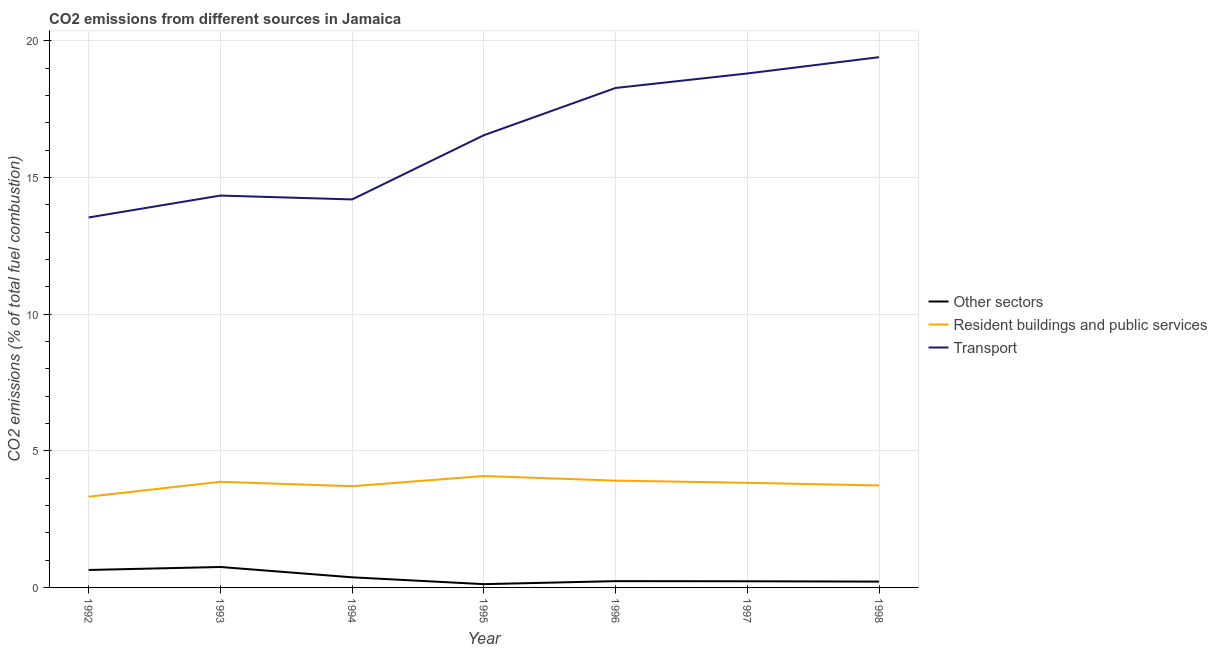Does the line corresponding to percentage of co2 emissions from transport intersect with the line corresponding to percentage of co2 emissions from resident buildings and public services?
Ensure brevity in your answer.  No. What is the percentage of co2 emissions from transport in 1994?
Make the answer very short. 14.2. Across all years, what is the maximum percentage of co2 emissions from transport?
Your answer should be very brief. 19.4. Across all years, what is the minimum percentage of co2 emissions from transport?
Your answer should be very brief. 13.54. In which year was the percentage of co2 emissions from transport minimum?
Keep it short and to the point. 1992. What is the total percentage of co2 emissions from other sectors in the graph?
Offer a very short reply. 2.55. What is the difference between the percentage of co2 emissions from resident buildings and public services in 1994 and that in 1998?
Provide a short and direct response. -0.03. What is the difference between the percentage of co2 emissions from resident buildings and public services in 1995 and the percentage of co2 emissions from transport in 1996?
Your answer should be very brief. -14.2. What is the average percentage of co2 emissions from resident buildings and public services per year?
Provide a succinct answer. 3.78. In the year 1994, what is the difference between the percentage of co2 emissions from other sectors and percentage of co2 emissions from resident buildings and public services?
Your response must be concise. -3.33. What is the ratio of the percentage of co2 emissions from resident buildings and public services in 1994 to that in 1998?
Offer a very short reply. 0.99. Is the percentage of co2 emissions from resident buildings and public services in 1993 less than that in 1998?
Your answer should be compact. No. Is the difference between the percentage of co2 emissions from other sectors in 1993 and 1997 greater than the difference between the percentage of co2 emissions from transport in 1993 and 1997?
Give a very brief answer. Yes. What is the difference between the highest and the second highest percentage of co2 emissions from resident buildings and public services?
Provide a succinct answer. 0.17. What is the difference between the highest and the lowest percentage of co2 emissions from transport?
Your answer should be very brief. 5.87. In how many years, is the percentage of co2 emissions from resident buildings and public services greater than the average percentage of co2 emissions from resident buildings and public services taken over all years?
Provide a short and direct response. 4. Is the sum of the percentage of co2 emissions from transport in 1996 and 1998 greater than the maximum percentage of co2 emissions from other sectors across all years?
Give a very brief answer. Yes. Is the percentage of co2 emissions from transport strictly less than the percentage of co2 emissions from resident buildings and public services over the years?
Offer a very short reply. No. How many lines are there?
Ensure brevity in your answer.  3. How many years are there in the graph?
Your response must be concise. 7. What is the difference between two consecutive major ticks on the Y-axis?
Keep it short and to the point. 5. Are the values on the major ticks of Y-axis written in scientific E-notation?
Ensure brevity in your answer.  No. Does the graph contain any zero values?
Ensure brevity in your answer.  No. Does the graph contain grids?
Provide a succinct answer. Yes. Where does the legend appear in the graph?
Provide a succinct answer. Center right. How many legend labels are there?
Your answer should be compact. 3. How are the legend labels stacked?
Give a very brief answer. Vertical. What is the title of the graph?
Make the answer very short. CO2 emissions from different sources in Jamaica. Does "Social insurance" appear as one of the legend labels in the graph?
Make the answer very short. No. What is the label or title of the X-axis?
Your answer should be very brief. Year. What is the label or title of the Y-axis?
Ensure brevity in your answer.  CO2 emissions (% of total fuel combustion). What is the CO2 emissions (% of total fuel combustion) of Other sectors in 1992?
Make the answer very short. 0.64. What is the CO2 emissions (% of total fuel combustion) of Resident buildings and public services in 1992?
Your response must be concise. 3.32. What is the CO2 emissions (% of total fuel combustion) in Transport in 1992?
Your answer should be compact. 13.54. What is the CO2 emissions (% of total fuel combustion) of Other sectors in 1993?
Ensure brevity in your answer.  0.75. What is the CO2 emissions (% of total fuel combustion) in Resident buildings and public services in 1993?
Your answer should be compact. 3.87. What is the CO2 emissions (% of total fuel combustion) in Transport in 1993?
Ensure brevity in your answer.  14.34. What is the CO2 emissions (% of total fuel combustion) of Other sectors in 1994?
Keep it short and to the point. 0.37. What is the CO2 emissions (% of total fuel combustion) in Resident buildings and public services in 1994?
Provide a succinct answer. 3.7. What is the CO2 emissions (% of total fuel combustion) of Transport in 1994?
Provide a short and direct response. 14.2. What is the CO2 emissions (% of total fuel combustion) in Other sectors in 1995?
Offer a very short reply. 0.12. What is the CO2 emissions (% of total fuel combustion) of Resident buildings and public services in 1995?
Offer a very short reply. 4.08. What is the CO2 emissions (% of total fuel combustion) of Transport in 1995?
Keep it short and to the point. 16.55. What is the CO2 emissions (% of total fuel combustion) in Other sectors in 1996?
Your answer should be very brief. 0.23. What is the CO2 emissions (% of total fuel combustion) in Resident buildings and public services in 1996?
Your answer should be compact. 3.91. What is the CO2 emissions (% of total fuel combustion) in Transport in 1996?
Keep it short and to the point. 18.28. What is the CO2 emissions (% of total fuel combustion) in Other sectors in 1997?
Provide a short and direct response. 0.23. What is the CO2 emissions (% of total fuel combustion) in Resident buildings and public services in 1997?
Provide a short and direct response. 3.83. What is the CO2 emissions (% of total fuel combustion) in Transport in 1997?
Make the answer very short. 18.81. What is the CO2 emissions (% of total fuel combustion) in Other sectors in 1998?
Make the answer very short. 0.21. What is the CO2 emissions (% of total fuel combustion) in Resident buildings and public services in 1998?
Provide a short and direct response. 3.73. What is the CO2 emissions (% of total fuel combustion) of Transport in 1998?
Your answer should be very brief. 19.4. Across all years, what is the maximum CO2 emissions (% of total fuel combustion) in Other sectors?
Keep it short and to the point. 0.75. Across all years, what is the maximum CO2 emissions (% of total fuel combustion) in Resident buildings and public services?
Provide a succinct answer. 4.08. Across all years, what is the maximum CO2 emissions (% of total fuel combustion) in Transport?
Ensure brevity in your answer.  19.4. Across all years, what is the minimum CO2 emissions (% of total fuel combustion) in Other sectors?
Offer a very short reply. 0.12. Across all years, what is the minimum CO2 emissions (% of total fuel combustion) of Resident buildings and public services?
Give a very brief answer. 3.32. Across all years, what is the minimum CO2 emissions (% of total fuel combustion) in Transport?
Make the answer very short. 13.54. What is the total CO2 emissions (% of total fuel combustion) in Other sectors in the graph?
Keep it short and to the point. 2.55. What is the total CO2 emissions (% of total fuel combustion) in Resident buildings and public services in the graph?
Give a very brief answer. 26.43. What is the total CO2 emissions (% of total fuel combustion) in Transport in the graph?
Offer a very short reply. 115.11. What is the difference between the CO2 emissions (% of total fuel combustion) in Other sectors in 1992 and that in 1993?
Your response must be concise. -0.11. What is the difference between the CO2 emissions (% of total fuel combustion) of Resident buildings and public services in 1992 and that in 1993?
Your answer should be very brief. -0.54. What is the difference between the CO2 emissions (% of total fuel combustion) of Transport in 1992 and that in 1993?
Provide a succinct answer. -0.8. What is the difference between the CO2 emissions (% of total fuel combustion) in Other sectors in 1992 and that in 1994?
Offer a very short reply. 0.27. What is the difference between the CO2 emissions (% of total fuel combustion) of Resident buildings and public services in 1992 and that in 1994?
Provide a short and direct response. -0.38. What is the difference between the CO2 emissions (% of total fuel combustion) in Transport in 1992 and that in 1994?
Give a very brief answer. -0.66. What is the difference between the CO2 emissions (% of total fuel combustion) of Other sectors in 1992 and that in 1995?
Provide a succinct answer. 0.52. What is the difference between the CO2 emissions (% of total fuel combustion) in Resident buildings and public services in 1992 and that in 1995?
Give a very brief answer. -0.76. What is the difference between the CO2 emissions (% of total fuel combustion) in Transport in 1992 and that in 1995?
Offer a terse response. -3.01. What is the difference between the CO2 emissions (% of total fuel combustion) of Other sectors in 1992 and that in 1996?
Provide a short and direct response. 0.41. What is the difference between the CO2 emissions (% of total fuel combustion) in Resident buildings and public services in 1992 and that in 1996?
Provide a short and direct response. -0.59. What is the difference between the CO2 emissions (% of total fuel combustion) in Transport in 1992 and that in 1996?
Your answer should be compact. -4.74. What is the difference between the CO2 emissions (% of total fuel combustion) in Other sectors in 1992 and that in 1997?
Provide a short and direct response. 0.41. What is the difference between the CO2 emissions (% of total fuel combustion) of Resident buildings and public services in 1992 and that in 1997?
Your response must be concise. -0.51. What is the difference between the CO2 emissions (% of total fuel combustion) of Transport in 1992 and that in 1997?
Provide a short and direct response. -5.27. What is the difference between the CO2 emissions (% of total fuel combustion) in Other sectors in 1992 and that in 1998?
Keep it short and to the point. 0.43. What is the difference between the CO2 emissions (% of total fuel combustion) of Resident buildings and public services in 1992 and that in 1998?
Keep it short and to the point. -0.41. What is the difference between the CO2 emissions (% of total fuel combustion) of Transport in 1992 and that in 1998?
Make the answer very short. -5.87. What is the difference between the CO2 emissions (% of total fuel combustion) of Other sectors in 1993 and that in 1994?
Offer a terse response. 0.38. What is the difference between the CO2 emissions (% of total fuel combustion) in Resident buildings and public services in 1993 and that in 1994?
Offer a very short reply. 0.16. What is the difference between the CO2 emissions (% of total fuel combustion) in Transport in 1993 and that in 1994?
Ensure brevity in your answer.  0.14. What is the difference between the CO2 emissions (% of total fuel combustion) of Other sectors in 1993 and that in 1995?
Your response must be concise. 0.63. What is the difference between the CO2 emissions (% of total fuel combustion) in Resident buildings and public services in 1993 and that in 1995?
Ensure brevity in your answer.  -0.21. What is the difference between the CO2 emissions (% of total fuel combustion) in Transport in 1993 and that in 1995?
Your answer should be very brief. -2.21. What is the difference between the CO2 emissions (% of total fuel combustion) of Other sectors in 1993 and that in 1996?
Keep it short and to the point. 0.52. What is the difference between the CO2 emissions (% of total fuel combustion) of Resident buildings and public services in 1993 and that in 1996?
Provide a short and direct response. -0.04. What is the difference between the CO2 emissions (% of total fuel combustion) of Transport in 1993 and that in 1996?
Your answer should be compact. -3.94. What is the difference between the CO2 emissions (% of total fuel combustion) of Other sectors in 1993 and that in 1997?
Provide a succinct answer. 0.52. What is the difference between the CO2 emissions (% of total fuel combustion) of Resident buildings and public services in 1993 and that in 1997?
Provide a succinct answer. 0.04. What is the difference between the CO2 emissions (% of total fuel combustion) of Transport in 1993 and that in 1997?
Give a very brief answer. -4.47. What is the difference between the CO2 emissions (% of total fuel combustion) in Other sectors in 1993 and that in 1998?
Keep it short and to the point. 0.53. What is the difference between the CO2 emissions (% of total fuel combustion) in Resident buildings and public services in 1993 and that in 1998?
Your answer should be compact. 0.13. What is the difference between the CO2 emissions (% of total fuel combustion) of Transport in 1993 and that in 1998?
Ensure brevity in your answer.  -5.06. What is the difference between the CO2 emissions (% of total fuel combustion) of Other sectors in 1994 and that in 1995?
Give a very brief answer. 0.25. What is the difference between the CO2 emissions (% of total fuel combustion) of Resident buildings and public services in 1994 and that in 1995?
Offer a very short reply. -0.37. What is the difference between the CO2 emissions (% of total fuel combustion) of Transport in 1994 and that in 1995?
Ensure brevity in your answer.  -2.35. What is the difference between the CO2 emissions (% of total fuel combustion) in Other sectors in 1994 and that in 1996?
Your response must be concise. 0.14. What is the difference between the CO2 emissions (% of total fuel combustion) of Resident buildings and public services in 1994 and that in 1996?
Provide a short and direct response. -0.2. What is the difference between the CO2 emissions (% of total fuel combustion) of Transport in 1994 and that in 1996?
Keep it short and to the point. -4.08. What is the difference between the CO2 emissions (% of total fuel combustion) of Other sectors in 1994 and that in 1997?
Your answer should be compact. 0.15. What is the difference between the CO2 emissions (% of total fuel combustion) of Resident buildings and public services in 1994 and that in 1997?
Your answer should be compact. -0.13. What is the difference between the CO2 emissions (% of total fuel combustion) in Transport in 1994 and that in 1997?
Ensure brevity in your answer.  -4.61. What is the difference between the CO2 emissions (% of total fuel combustion) in Other sectors in 1994 and that in 1998?
Provide a succinct answer. 0.16. What is the difference between the CO2 emissions (% of total fuel combustion) of Resident buildings and public services in 1994 and that in 1998?
Offer a terse response. -0.03. What is the difference between the CO2 emissions (% of total fuel combustion) in Transport in 1994 and that in 1998?
Offer a very short reply. -5.21. What is the difference between the CO2 emissions (% of total fuel combustion) of Other sectors in 1995 and that in 1996?
Make the answer very short. -0.11. What is the difference between the CO2 emissions (% of total fuel combustion) of Resident buildings and public services in 1995 and that in 1996?
Ensure brevity in your answer.  0.17. What is the difference between the CO2 emissions (% of total fuel combustion) in Transport in 1995 and that in 1996?
Your response must be concise. -1.73. What is the difference between the CO2 emissions (% of total fuel combustion) in Other sectors in 1995 and that in 1997?
Make the answer very short. -0.11. What is the difference between the CO2 emissions (% of total fuel combustion) in Resident buildings and public services in 1995 and that in 1997?
Offer a very short reply. 0.25. What is the difference between the CO2 emissions (% of total fuel combustion) in Transport in 1995 and that in 1997?
Provide a succinct answer. -2.26. What is the difference between the CO2 emissions (% of total fuel combustion) in Other sectors in 1995 and that in 1998?
Your response must be concise. -0.09. What is the difference between the CO2 emissions (% of total fuel combustion) of Resident buildings and public services in 1995 and that in 1998?
Offer a very short reply. 0.35. What is the difference between the CO2 emissions (% of total fuel combustion) of Transport in 1995 and that in 1998?
Offer a very short reply. -2.86. What is the difference between the CO2 emissions (% of total fuel combustion) of Other sectors in 1996 and that in 1997?
Keep it short and to the point. 0. What is the difference between the CO2 emissions (% of total fuel combustion) of Resident buildings and public services in 1996 and that in 1997?
Make the answer very short. 0.08. What is the difference between the CO2 emissions (% of total fuel combustion) in Transport in 1996 and that in 1997?
Ensure brevity in your answer.  -0.53. What is the difference between the CO2 emissions (% of total fuel combustion) in Other sectors in 1996 and that in 1998?
Make the answer very short. 0.02. What is the difference between the CO2 emissions (% of total fuel combustion) of Resident buildings and public services in 1996 and that in 1998?
Offer a terse response. 0.18. What is the difference between the CO2 emissions (% of total fuel combustion) in Transport in 1996 and that in 1998?
Offer a terse response. -1.13. What is the difference between the CO2 emissions (% of total fuel combustion) of Other sectors in 1997 and that in 1998?
Give a very brief answer. 0.01. What is the difference between the CO2 emissions (% of total fuel combustion) in Resident buildings and public services in 1997 and that in 1998?
Make the answer very short. 0.1. What is the difference between the CO2 emissions (% of total fuel combustion) of Transport in 1997 and that in 1998?
Your answer should be compact. -0.6. What is the difference between the CO2 emissions (% of total fuel combustion) in Other sectors in 1992 and the CO2 emissions (% of total fuel combustion) in Resident buildings and public services in 1993?
Your response must be concise. -3.23. What is the difference between the CO2 emissions (% of total fuel combustion) in Other sectors in 1992 and the CO2 emissions (% of total fuel combustion) in Transport in 1993?
Ensure brevity in your answer.  -13.7. What is the difference between the CO2 emissions (% of total fuel combustion) of Resident buildings and public services in 1992 and the CO2 emissions (% of total fuel combustion) of Transport in 1993?
Give a very brief answer. -11.02. What is the difference between the CO2 emissions (% of total fuel combustion) of Other sectors in 1992 and the CO2 emissions (% of total fuel combustion) of Resident buildings and public services in 1994?
Give a very brief answer. -3.07. What is the difference between the CO2 emissions (% of total fuel combustion) in Other sectors in 1992 and the CO2 emissions (% of total fuel combustion) in Transport in 1994?
Ensure brevity in your answer.  -13.56. What is the difference between the CO2 emissions (% of total fuel combustion) of Resident buildings and public services in 1992 and the CO2 emissions (% of total fuel combustion) of Transport in 1994?
Your answer should be compact. -10.88. What is the difference between the CO2 emissions (% of total fuel combustion) of Other sectors in 1992 and the CO2 emissions (% of total fuel combustion) of Resident buildings and public services in 1995?
Your answer should be very brief. -3.44. What is the difference between the CO2 emissions (% of total fuel combustion) of Other sectors in 1992 and the CO2 emissions (% of total fuel combustion) of Transport in 1995?
Provide a succinct answer. -15.91. What is the difference between the CO2 emissions (% of total fuel combustion) in Resident buildings and public services in 1992 and the CO2 emissions (% of total fuel combustion) in Transport in 1995?
Offer a very short reply. -13.23. What is the difference between the CO2 emissions (% of total fuel combustion) in Other sectors in 1992 and the CO2 emissions (% of total fuel combustion) in Resident buildings and public services in 1996?
Give a very brief answer. -3.27. What is the difference between the CO2 emissions (% of total fuel combustion) in Other sectors in 1992 and the CO2 emissions (% of total fuel combustion) in Transport in 1996?
Ensure brevity in your answer.  -17.64. What is the difference between the CO2 emissions (% of total fuel combustion) in Resident buildings and public services in 1992 and the CO2 emissions (% of total fuel combustion) in Transport in 1996?
Ensure brevity in your answer.  -14.96. What is the difference between the CO2 emissions (% of total fuel combustion) of Other sectors in 1992 and the CO2 emissions (% of total fuel combustion) of Resident buildings and public services in 1997?
Offer a terse response. -3.19. What is the difference between the CO2 emissions (% of total fuel combustion) of Other sectors in 1992 and the CO2 emissions (% of total fuel combustion) of Transport in 1997?
Your answer should be compact. -18.17. What is the difference between the CO2 emissions (% of total fuel combustion) of Resident buildings and public services in 1992 and the CO2 emissions (% of total fuel combustion) of Transport in 1997?
Your response must be concise. -15.49. What is the difference between the CO2 emissions (% of total fuel combustion) in Other sectors in 1992 and the CO2 emissions (% of total fuel combustion) in Resident buildings and public services in 1998?
Your answer should be compact. -3.09. What is the difference between the CO2 emissions (% of total fuel combustion) in Other sectors in 1992 and the CO2 emissions (% of total fuel combustion) in Transport in 1998?
Provide a succinct answer. -18.76. What is the difference between the CO2 emissions (% of total fuel combustion) in Resident buildings and public services in 1992 and the CO2 emissions (% of total fuel combustion) in Transport in 1998?
Keep it short and to the point. -16.08. What is the difference between the CO2 emissions (% of total fuel combustion) of Other sectors in 1993 and the CO2 emissions (% of total fuel combustion) of Resident buildings and public services in 1994?
Ensure brevity in your answer.  -2.96. What is the difference between the CO2 emissions (% of total fuel combustion) in Other sectors in 1993 and the CO2 emissions (% of total fuel combustion) in Transport in 1994?
Offer a very short reply. -13.45. What is the difference between the CO2 emissions (% of total fuel combustion) of Resident buildings and public services in 1993 and the CO2 emissions (% of total fuel combustion) of Transport in 1994?
Make the answer very short. -10.33. What is the difference between the CO2 emissions (% of total fuel combustion) in Other sectors in 1993 and the CO2 emissions (% of total fuel combustion) in Resident buildings and public services in 1995?
Offer a very short reply. -3.33. What is the difference between the CO2 emissions (% of total fuel combustion) in Other sectors in 1993 and the CO2 emissions (% of total fuel combustion) in Transport in 1995?
Provide a short and direct response. -15.8. What is the difference between the CO2 emissions (% of total fuel combustion) in Resident buildings and public services in 1993 and the CO2 emissions (% of total fuel combustion) in Transport in 1995?
Give a very brief answer. -12.68. What is the difference between the CO2 emissions (% of total fuel combustion) in Other sectors in 1993 and the CO2 emissions (% of total fuel combustion) in Resident buildings and public services in 1996?
Make the answer very short. -3.16. What is the difference between the CO2 emissions (% of total fuel combustion) in Other sectors in 1993 and the CO2 emissions (% of total fuel combustion) in Transport in 1996?
Make the answer very short. -17.53. What is the difference between the CO2 emissions (% of total fuel combustion) in Resident buildings and public services in 1993 and the CO2 emissions (% of total fuel combustion) in Transport in 1996?
Offer a terse response. -14.41. What is the difference between the CO2 emissions (% of total fuel combustion) of Other sectors in 1993 and the CO2 emissions (% of total fuel combustion) of Resident buildings and public services in 1997?
Offer a terse response. -3.08. What is the difference between the CO2 emissions (% of total fuel combustion) in Other sectors in 1993 and the CO2 emissions (% of total fuel combustion) in Transport in 1997?
Your response must be concise. -18.06. What is the difference between the CO2 emissions (% of total fuel combustion) of Resident buildings and public services in 1993 and the CO2 emissions (% of total fuel combustion) of Transport in 1997?
Your answer should be compact. -14.94. What is the difference between the CO2 emissions (% of total fuel combustion) in Other sectors in 1993 and the CO2 emissions (% of total fuel combustion) in Resident buildings and public services in 1998?
Give a very brief answer. -2.98. What is the difference between the CO2 emissions (% of total fuel combustion) in Other sectors in 1993 and the CO2 emissions (% of total fuel combustion) in Transport in 1998?
Your answer should be very brief. -18.65. What is the difference between the CO2 emissions (% of total fuel combustion) in Resident buildings and public services in 1993 and the CO2 emissions (% of total fuel combustion) in Transport in 1998?
Give a very brief answer. -15.54. What is the difference between the CO2 emissions (% of total fuel combustion) in Other sectors in 1994 and the CO2 emissions (% of total fuel combustion) in Resident buildings and public services in 1995?
Ensure brevity in your answer.  -3.71. What is the difference between the CO2 emissions (% of total fuel combustion) in Other sectors in 1994 and the CO2 emissions (% of total fuel combustion) in Transport in 1995?
Make the answer very short. -16.18. What is the difference between the CO2 emissions (% of total fuel combustion) in Resident buildings and public services in 1994 and the CO2 emissions (% of total fuel combustion) in Transport in 1995?
Your answer should be compact. -12.84. What is the difference between the CO2 emissions (% of total fuel combustion) of Other sectors in 1994 and the CO2 emissions (% of total fuel combustion) of Resident buildings and public services in 1996?
Offer a terse response. -3.54. What is the difference between the CO2 emissions (% of total fuel combustion) of Other sectors in 1994 and the CO2 emissions (% of total fuel combustion) of Transport in 1996?
Your answer should be compact. -17.91. What is the difference between the CO2 emissions (% of total fuel combustion) of Resident buildings and public services in 1994 and the CO2 emissions (% of total fuel combustion) of Transport in 1996?
Keep it short and to the point. -14.57. What is the difference between the CO2 emissions (% of total fuel combustion) of Other sectors in 1994 and the CO2 emissions (% of total fuel combustion) of Resident buildings and public services in 1997?
Keep it short and to the point. -3.46. What is the difference between the CO2 emissions (% of total fuel combustion) of Other sectors in 1994 and the CO2 emissions (% of total fuel combustion) of Transport in 1997?
Make the answer very short. -18.44. What is the difference between the CO2 emissions (% of total fuel combustion) in Resident buildings and public services in 1994 and the CO2 emissions (% of total fuel combustion) in Transport in 1997?
Provide a short and direct response. -15.1. What is the difference between the CO2 emissions (% of total fuel combustion) in Other sectors in 1994 and the CO2 emissions (% of total fuel combustion) in Resident buildings and public services in 1998?
Make the answer very short. -3.36. What is the difference between the CO2 emissions (% of total fuel combustion) in Other sectors in 1994 and the CO2 emissions (% of total fuel combustion) in Transport in 1998?
Offer a terse response. -19.03. What is the difference between the CO2 emissions (% of total fuel combustion) of Resident buildings and public services in 1994 and the CO2 emissions (% of total fuel combustion) of Transport in 1998?
Your response must be concise. -15.7. What is the difference between the CO2 emissions (% of total fuel combustion) in Other sectors in 1995 and the CO2 emissions (% of total fuel combustion) in Resident buildings and public services in 1996?
Offer a very short reply. -3.79. What is the difference between the CO2 emissions (% of total fuel combustion) of Other sectors in 1995 and the CO2 emissions (% of total fuel combustion) of Transport in 1996?
Offer a terse response. -18.16. What is the difference between the CO2 emissions (% of total fuel combustion) in Resident buildings and public services in 1995 and the CO2 emissions (% of total fuel combustion) in Transport in 1996?
Make the answer very short. -14.2. What is the difference between the CO2 emissions (% of total fuel combustion) in Other sectors in 1995 and the CO2 emissions (% of total fuel combustion) in Resident buildings and public services in 1997?
Your response must be concise. -3.71. What is the difference between the CO2 emissions (% of total fuel combustion) in Other sectors in 1995 and the CO2 emissions (% of total fuel combustion) in Transport in 1997?
Make the answer very short. -18.69. What is the difference between the CO2 emissions (% of total fuel combustion) in Resident buildings and public services in 1995 and the CO2 emissions (% of total fuel combustion) in Transport in 1997?
Make the answer very short. -14.73. What is the difference between the CO2 emissions (% of total fuel combustion) in Other sectors in 1995 and the CO2 emissions (% of total fuel combustion) in Resident buildings and public services in 1998?
Provide a succinct answer. -3.61. What is the difference between the CO2 emissions (% of total fuel combustion) in Other sectors in 1995 and the CO2 emissions (% of total fuel combustion) in Transport in 1998?
Ensure brevity in your answer.  -19.28. What is the difference between the CO2 emissions (% of total fuel combustion) in Resident buildings and public services in 1995 and the CO2 emissions (% of total fuel combustion) in Transport in 1998?
Offer a terse response. -15.33. What is the difference between the CO2 emissions (% of total fuel combustion) of Other sectors in 1996 and the CO2 emissions (% of total fuel combustion) of Resident buildings and public services in 1997?
Provide a short and direct response. -3.6. What is the difference between the CO2 emissions (% of total fuel combustion) of Other sectors in 1996 and the CO2 emissions (% of total fuel combustion) of Transport in 1997?
Make the answer very short. -18.58. What is the difference between the CO2 emissions (% of total fuel combustion) in Resident buildings and public services in 1996 and the CO2 emissions (% of total fuel combustion) in Transport in 1997?
Offer a terse response. -14.9. What is the difference between the CO2 emissions (% of total fuel combustion) of Other sectors in 1996 and the CO2 emissions (% of total fuel combustion) of Resident buildings and public services in 1998?
Provide a short and direct response. -3.5. What is the difference between the CO2 emissions (% of total fuel combustion) of Other sectors in 1996 and the CO2 emissions (% of total fuel combustion) of Transport in 1998?
Keep it short and to the point. -19.17. What is the difference between the CO2 emissions (% of total fuel combustion) of Resident buildings and public services in 1996 and the CO2 emissions (% of total fuel combustion) of Transport in 1998?
Ensure brevity in your answer.  -15.49. What is the difference between the CO2 emissions (% of total fuel combustion) of Other sectors in 1997 and the CO2 emissions (% of total fuel combustion) of Resident buildings and public services in 1998?
Your answer should be compact. -3.51. What is the difference between the CO2 emissions (% of total fuel combustion) of Other sectors in 1997 and the CO2 emissions (% of total fuel combustion) of Transport in 1998?
Give a very brief answer. -19.18. What is the difference between the CO2 emissions (% of total fuel combustion) in Resident buildings and public services in 1997 and the CO2 emissions (% of total fuel combustion) in Transport in 1998?
Offer a terse response. -15.57. What is the average CO2 emissions (% of total fuel combustion) of Other sectors per year?
Make the answer very short. 0.36. What is the average CO2 emissions (% of total fuel combustion) of Resident buildings and public services per year?
Give a very brief answer. 3.78. What is the average CO2 emissions (% of total fuel combustion) of Transport per year?
Your answer should be compact. 16.44. In the year 1992, what is the difference between the CO2 emissions (% of total fuel combustion) in Other sectors and CO2 emissions (% of total fuel combustion) in Resident buildings and public services?
Offer a very short reply. -2.68. In the year 1992, what is the difference between the CO2 emissions (% of total fuel combustion) in Other sectors and CO2 emissions (% of total fuel combustion) in Transport?
Your response must be concise. -12.9. In the year 1992, what is the difference between the CO2 emissions (% of total fuel combustion) of Resident buildings and public services and CO2 emissions (% of total fuel combustion) of Transport?
Ensure brevity in your answer.  -10.22. In the year 1993, what is the difference between the CO2 emissions (% of total fuel combustion) in Other sectors and CO2 emissions (% of total fuel combustion) in Resident buildings and public services?
Provide a succinct answer. -3.12. In the year 1993, what is the difference between the CO2 emissions (% of total fuel combustion) in Other sectors and CO2 emissions (% of total fuel combustion) in Transport?
Ensure brevity in your answer.  -13.59. In the year 1993, what is the difference between the CO2 emissions (% of total fuel combustion) in Resident buildings and public services and CO2 emissions (% of total fuel combustion) in Transport?
Offer a very short reply. -10.47. In the year 1994, what is the difference between the CO2 emissions (% of total fuel combustion) of Other sectors and CO2 emissions (% of total fuel combustion) of Transport?
Provide a short and direct response. -13.83. In the year 1994, what is the difference between the CO2 emissions (% of total fuel combustion) in Resident buildings and public services and CO2 emissions (% of total fuel combustion) in Transport?
Your response must be concise. -10.49. In the year 1995, what is the difference between the CO2 emissions (% of total fuel combustion) of Other sectors and CO2 emissions (% of total fuel combustion) of Resident buildings and public services?
Keep it short and to the point. -3.96. In the year 1995, what is the difference between the CO2 emissions (% of total fuel combustion) of Other sectors and CO2 emissions (% of total fuel combustion) of Transport?
Ensure brevity in your answer.  -16.43. In the year 1995, what is the difference between the CO2 emissions (% of total fuel combustion) in Resident buildings and public services and CO2 emissions (% of total fuel combustion) in Transport?
Offer a very short reply. -12.47. In the year 1996, what is the difference between the CO2 emissions (% of total fuel combustion) in Other sectors and CO2 emissions (% of total fuel combustion) in Resident buildings and public services?
Give a very brief answer. -3.68. In the year 1996, what is the difference between the CO2 emissions (% of total fuel combustion) of Other sectors and CO2 emissions (% of total fuel combustion) of Transport?
Provide a short and direct response. -18.05. In the year 1996, what is the difference between the CO2 emissions (% of total fuel combustion) in Resident buildings and public services and CO2 emissions (% of total fuel combustion) in Transport?
Ensure brevity in your answer.  -14.37. In the year 1997, what is the difference between the CO2 emissions (% of total fuel combustion) of Other sectors and CO2 emissions (% of total fuel combustion) of Resident buildings and public services?
Give a very brief answer. -3.6. In the year 1997, what is the difference between the CO2 emissions (% of total fuel combustion) in Other sectors and CO2 emissions (% of total fuel combustion) in Transport?
Your answer should be compact. -18.58. In the year 1997, what is the difference between the CO2 emissions (% of total fuel combustion) in Resident buildings and public services and CO2 emissions (% of total fuel combustion) in Transport?
Give a very brief answer. -14.98. In the year 1998, what is the difference between the CO2 emissions (% of total fuel combustion) of Other sectors and CO2 emissions (% of total fuel combustion) of Resident buildings and public services?
Your response must be concise. -3.52. In the year 1998, what is the difference between the CO2 emissions (% of total fuel combustion) in Other sectors and CO2 emissions (% of total fuel combustion) in Transport?
Your response must be concise. -19.19. In the year 1998, what is the difference between the CO2 emissions (% of total fuel combustion) in Resident buildings and public services and CO2 emissions (% of total fuel combustion) in Transport?
Offer a terse response. -15.67. What is the ratio of the CO2 emissions (% of total fuel combustion) in Other sectors in 1992 to that in 1993?
Give a very brief answer. 0.85. What is the ratio of the CO2 emissions (% of total fuel combustion) in Resident buildings and public services in 1992 to that in 1993?
Your response must be concise. 0.86. What is the ratio of the CO2 emissions (% of total fuel combustion) of Transport in 1992 to that in 1993?
Your answer should be compact. 0.94. What is the ratio of the CO2 emissions (% of total fuel combustion) in Other sectors in 1992 to that in 1994?
Your answer should be very brief. 1.72. What is the ratio of the CO2 emissions (% of total fuel combustion) of Resident buildings and public services in 1992 to that in 1994?
Your answer should be compact. 0.9. What is the ratio of the CO2 emissions (% of total fuel combustion) of Transport in 1992 to that in 1994?
Provide a short and direct response. 0.95. What is the ratio of the CO2 emissions (% of total fuel combustion) of Other sectors in 1992 to that in 1995?
Make the answer very short. 5.33. What is the ratio of the CO2 emissions (% of total fuel combustion) in Resident buildings and public services in 1992 to that in 1995?
Give a very brief answer. 0.81. What is the ratio of the CO2 emissions (% of total fuel combustion) in Transport in 1992 to that in 1995?
Make the answer very short. 0.82. What is the ratio of the CO2 emissions (% of total fuel combustion) of Other sectors in 1992 to that in 1996?
Your answer should be compact. 2.78. What is the ratio of the CO2 emissions (% of total fuel combustion) in Resident buildings and public services in 1992 to that in 1996?
Make the answer very short. 0.85. What is the ratio of the CO2 emissions (% of total fuel combustion) of Transport in 1992 to that in 1996?
Offer a terse response. 0.74. What is the ratio of the CO2 emissions (% of total fuel combustion) in Other sectors in 1992 to that in 1997?
Make the answer very short. 2.84. What is the ratio of the CO2 emissions (% of total fuel combustion) in Resident buildings and public services in 1992 to that in 1997?
Give a very brief answer. 0.87. What is the ratio of the CO2 emissions (% of total fuel combustion) in Transport in 1992 to that in 1997?
Provide a short and direct response. 0.72. What is the ratio of the CO2 emissions (% of total fuel combustion) in Other sectors in 1992 to that in 1998?
Provide a short and direct response. 2.99. What is the ratio of the CO2 emissions (% of total fuel combustion) in Resident buildings and public services in 1992 to that in 1998?
Provide a succinct answer. 0.89. What is the ratio of the CO2 emissions (% of total fuel combustion) of Transport in 1992 to that in 1998?
Offer a terse response. 0.7. What is the ratio of the CO2 emissions (% of total fuel combustion) of Other sectors in 1993 to that in 1994?
Your answer should be compact. 2.02. What is the ratio of the CO2 emissions (% of total fuel combustion) in Resident buildings and public services in 1993 to that in 1994?
Offer a very short reply. 1.04. What is the ratio of the CO2 emissions (% of total fuel combustion) in Other sectors in 1993 to that in 1995?
Your answer should be very brief. 6.24. What is the ratio of the CO2 emissions (% of total fuel combustion) in Resident buildings and public services in 1993 to that in 1995?
Offer a very short reply. 0.95. What is the ratio of the CO2 emissions (% of total fuel combustion) in Transport in 1993 to that in 1995?
Keep it short and to the point. 0.87. What is the ratio of the CO2 emissions (% of total fuel combustion) in Other sectors in 1993 to that in 1996?
Ensure brevity in your answer.  3.25. What is the ratio of the CO2 emissions (% of total fuel combustion) in Transport in 1993 to that in 1996?
Your answer should be very brief. 0.78. What is the ratio of the CO2 emissions (% of total fuel combustion) in Other sectors in 1993 to that in 1997?
Offer a terse response. 3.32. What is the ratio of the CO2 emissions (% of total fuel combustion) in Resident buildings and public services in 1993 to that in 1997?
Offer a very short reply. 1.01. What is the ratio of the CO2 emissions (% of total fuel combustion) in Transport in 1993 to that in 1997?
Provide a short and direct response. 0.76. What is the ratio of the CO2 emissions (% of total fuel combustion) in Other sectors in 1993 to that in 1998?
Provide a short and direct response. 3.51. What is the ratio of the CO2 emissions (% of total fuel combustion) in Resident buildings and public services in 1993 to that in 1998?
Offer a very short reply. 1.04. What is the ratio of the CO2 emissions (% of total fuel combustion) of Transport in 1993 to that in 1998?
Your answer should be very brief. 0.74. What is the ratio of the CO2 emissions (% of total fuel combustion) in Other sectors in 1994 to that in 1995?
Make the answer very short. 3.09. What is the ratio of the CO2 emissions (% of total fuel combustion) of Resident buildings and public services in 1994 to that in 1995?
Offer a terse response. 0.91. What is the ratio of the CO2 emissions (% of total fuel combustion) of Transport in 1994 to that in 1995?
Ensure brevity in your answer.  0.86. What is the ratio of the CO2 emissions (% of total fuel combustion) of Other sectors in 1994 to that in 1996?
Keep it short and to the point. 1.61. What is the ratio of the CO2 emissions (% of total fuel combustion) of Resident buildings and public services in 1994 to that in 1996?
Provide a short and direct response. 0.95. What is the ratio of the CO2 emissions (% of total fuel combustion) in Transport in 1994 to that in 1996?
Your answer should be very brief. 0.78. What is the ratio of the CO2 emissions (% of total fuel combustion) in Other sectors in 1994 to that in 1997?
Make the answer very short. 1.64. What is the ratio of the CO2 emissions (% of total fuel combustion) of Resident buildings and public services in 1994 to that in 1997?
Provide a short and direct response. 0.97. What is the ratio of the CO2 emissions (% of total fuel combustion) of Transport in 1994 to that in 1997?
Provide a short and direct response. 0.75. What is the ratio of the CO2 emissions (% of total fuel combustion) of Other sectors in 1994 to that in 1998?
Offer a terse response. 1.74. What is the ratio of the CO2 emissions (% of total fuel combustion) in Resident buildings and public services in 1994 to that in 1998?
Your response must be concise. 0.99. What is the ratio of the CO2 emissions (% of total fuel combustion) in Transport in 1994 to that in 1998?
Ensure brevity in your answer.  0.73. What is the ratio of the CO2 emissions (% of total fuel combustion) of Other sectors in 1995 to that in 1996?
Your response must be concise. 0.52. What is the ratio of the CO2 emissions (% of total fuel combustion) of Resident buildings and public services in 1995 to that in 1996?
Your answer should be compact. 1.04. What is the ratio of the CO2 emissions (% of total fuel combustion) in Transport in 1995 to that in 1996?
Provide a short and direct response. 0.91. What is the ratio of the CO2 emissions (% of total fuel combustion) of Other sectors in 1995 to that in 1997?
Provide a short and direct response. 0.53. What is the ratio of the CO2 emissions (% of total fuel combustion) in Resident buildings and public services in 1995 to that in 1997?
Keep it short and to the point. 1.06. What is the ratio of the CO2 emissions (% of total fuel combustion) of Transport in 1995 to that in 1997?
Give a very brief answer. 0.88. What is the ratio of the CO2 emissions (% of total fuel combustion) in Other sectors in 1995 to that in 1998?
Make the answer very short. 0.56. What is the ratio of the CO2 emissions (% of total fuel combustion) of Resident buildings and public services in 1995 to that in 1998?
Provide a short and direct response. 1.09. What is the ratio of the CO2 emissions (% of total fuel combustion) in Transport in 1995 to that in 1998?
Offer a terse response. 0.85. What is the ratio of the CO2 emissions (% of total fuel combustion) of Other sectors in 1996 to that in 1997?
Provide a succinct answer. 1.02. What is the ratio of the CO2 emissions (% of total fuel combustion) in Resident buildings and public services in 1996 to that in 1997?
Give a very brief answer. 1.02. What is the ratio of the CO2 emissions (% of total fuel combustion) in Transport in 1996 to that in 1997?
Offer a terse response. 0.97. What is the ratio of the CO2 emissions (% of total fuel combustion) of Other sectors in 1996 to that in 1998?
Give a very brief answer. 1.08. What is the ratio of the CO2 emissions (% of total fuel combustion) in Resident buildings and public services in 1996 to that in 1998?
Your answer should be very brief. 1.05. What is the ratio of the CO2 emissions (% of total fuel combustion) of Transport in 1996 to that in 1998?
Offer a terse response. 0.94. What is the ratio of the CO2 emissions (% of total fuel combustion) in Other sectors in 1997 to that in 1998?
Your answer should be compact. 1.06. What is the ratio of the CO2 emissions (% of total fuel combustion) in Resident buildings and public services in 1997 to that in 1998?
Make the answer very short. 1.03. What is the ratio of the CO2 emissions (% of total fuel combustion) in Transport in 1997 to that in 1998?
Provide a short and direct response. 0.97. What is the difference between the highest and the second highest CO2 emissions (% of total fuel combustion) in Other sectors?
Your answer should be compact. 0.11. What is the difference between the highest and the second highest CO2 emissions (% of total fuel combustion) in Resident buildings and public services?
Provide a succinct answer. 0.17. What is the difference between the highest and the second highest CO2 emissions (% of total fuel combustion) of Transport?
Your response must be concise. 0.6. What is the difference between the highest and the lowest CO2 emissions (% of total fuel combustion) in Other sectors?
Your response must be concise. 0.63. What is the difference between the highest and the lowest CO2 emissions (% of total fuel combustion) in Resident buildings and public services?
Provide a succinct answer. 0.76. What is the difference between the highest and the lowest CO2 emissions (% of total fuel combustion) in Transport?
Your answer should be very brief. 5.87. 